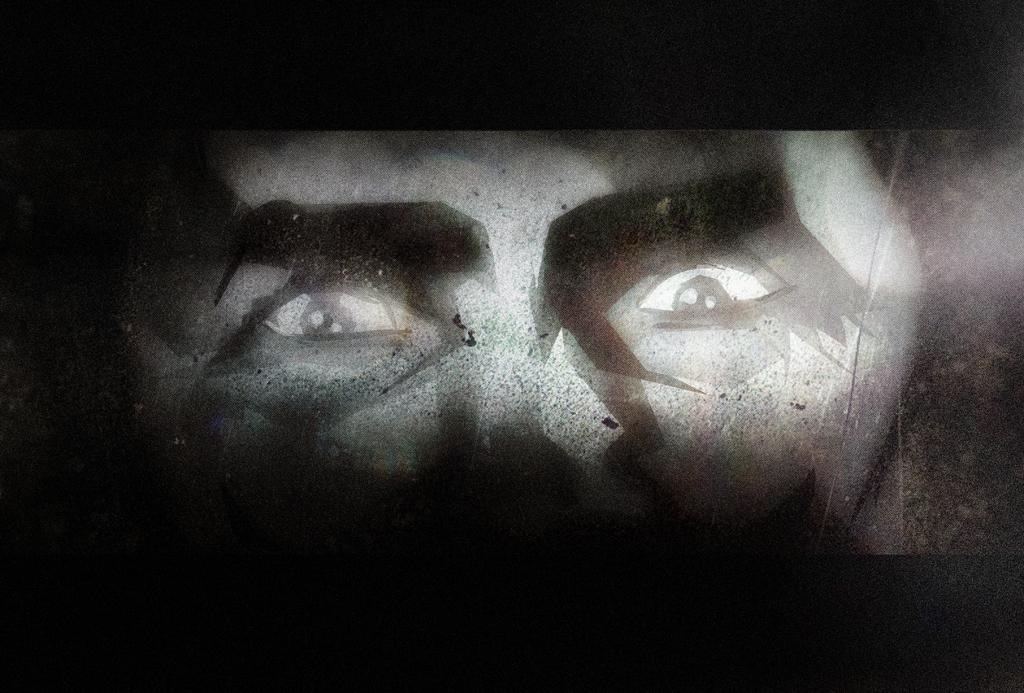What is the main subject of the image? There is a person's face in the image. Can you describe the background of the image? The background of the image is dark. What type of boundary is depicted in the image? There is no boundary present in the image; it features a person's face and a dark background. What memories does the person in the image have? We cannot determine the person's memories from the image, as it only shows their face and a dark background. 